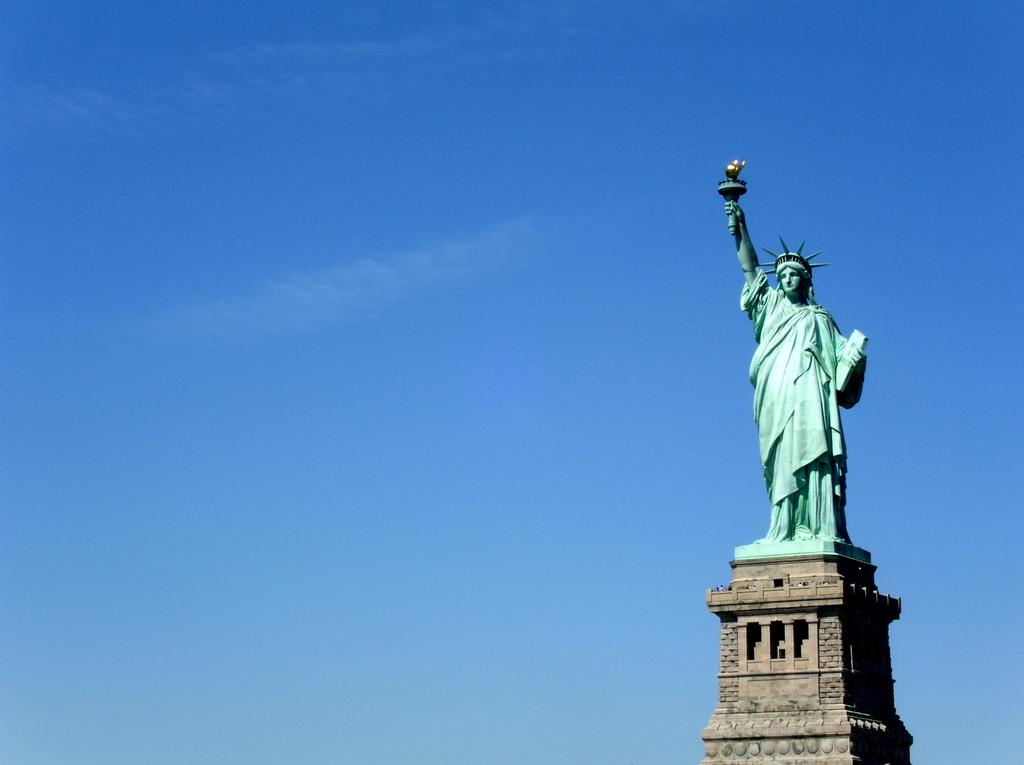Where was the image taken? The image was taken outdoors. What can be seen in the background of the image? There is a sky with clouds visible in the background. What is the main subject on the right side of the image? There is a statue of liberty on a tower on the right side of the image. What type of list is being used by the statue of liberty in the image? There is no list present in the image, as it features a statue of liberty on a tower. How does the beginner cabbage farmer contribute to the scene in the image? There is no cabbage farmer present in the image, so it's not possible to determine their contribution to the scene. 